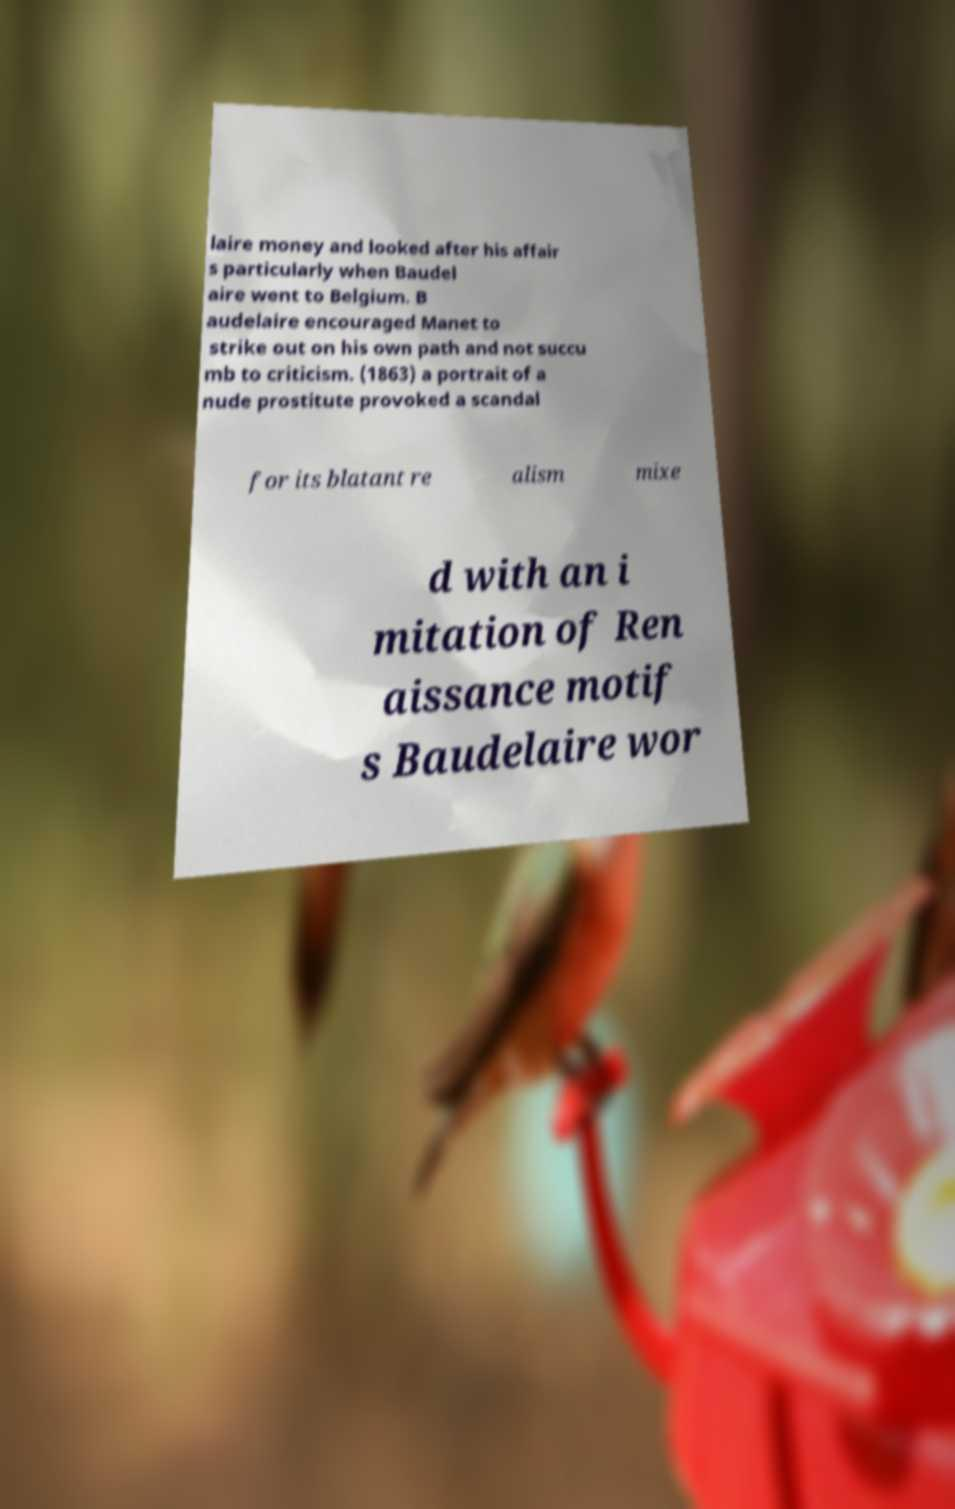I need the written content from this picture converted into text. Can you do that? laire money and looked after his affair s particularly when Baudel aire went to Belgium. B audelaire encouraged Manet to strike out on his own path and not succu mb to criticism. (1863) a portrait of a nude prostitute provoked a scandal for its blatant re alism mixe d with an i mitation of Ren aissance motif s Baudelaire wor 